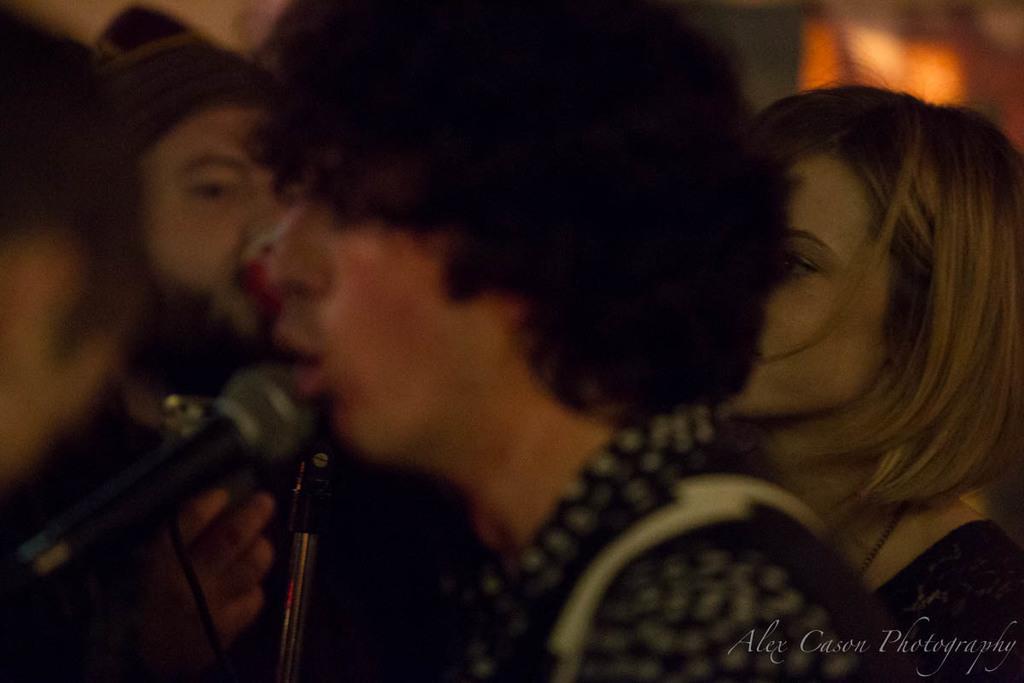Could you give a brief overview of what you see in this image? In the middle of the image there is a person. In front of the person there is a mic and also there is a stand. Behind the person there are few people and also there is a blur background. In the bottom right corner of the image there is something written on it. 